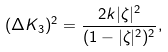<formula> <loc_0><loc_0><loc_500><loc_500>( \Delta K _ { 3 } ) ^ { 2 } = \frac { 2 k | \zeta | ^ { 2 } } { ( 1 - | \zeta | ^ { 2 } ) ^ { 2 } } ,</formula> 